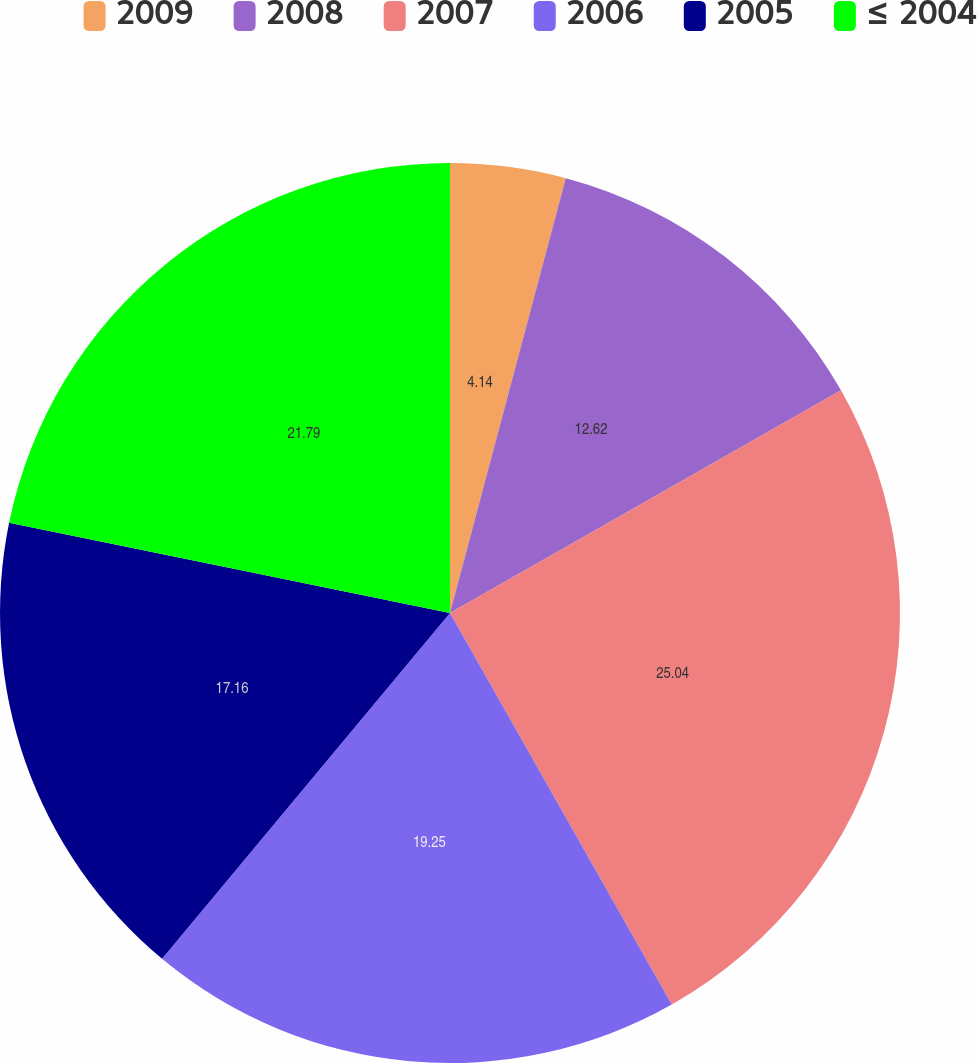Convert chart to OTSL. <chart><loc_0><loc_0><loc_500><loc_500><pie_chart><fcel>2009<fcel>2008<fcel>2007<fcel>2006<fcel>2005<fcel>≤ 2004<nl><fcel>4.14%<fcel>12.62%<fcel>25.04%<fcel>19.25%<fcel>17.16%<fcel>21.79%<nl></chart> 